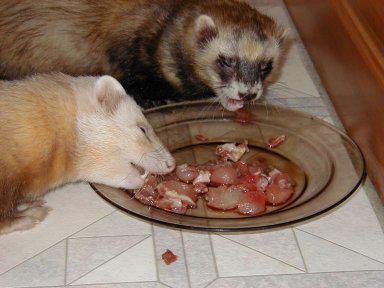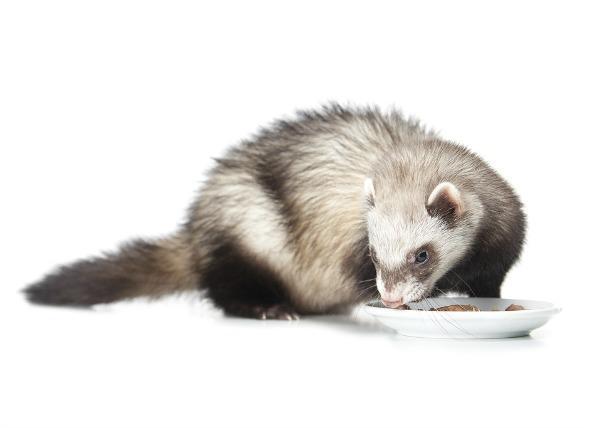The first image is the image on the left, the second image is the image on the right. Considering the images on both sides, is "The little animal in one image has its mouth wide open with tongue and two lower teeth showing, while a second little animal is eating in the second image." valid? Answer yes or no. No. The first image is the image on the left, the second image is the image on the right. For the images displayed, is the sentence "A ferret with no food in front of it is """"licking its chops"""" with an upturned tongue." factually correct? Answer yes or no. No. 